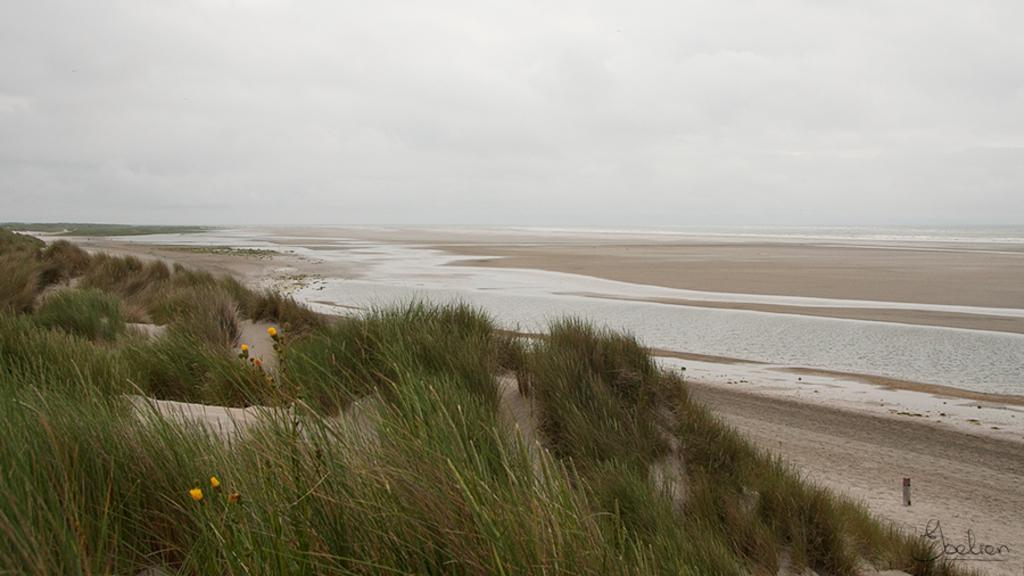Describe this image in one or two sentences. In this image there is grass, flowers, water and cloudy sky. At the bottom right side of the image there is a watermark. 